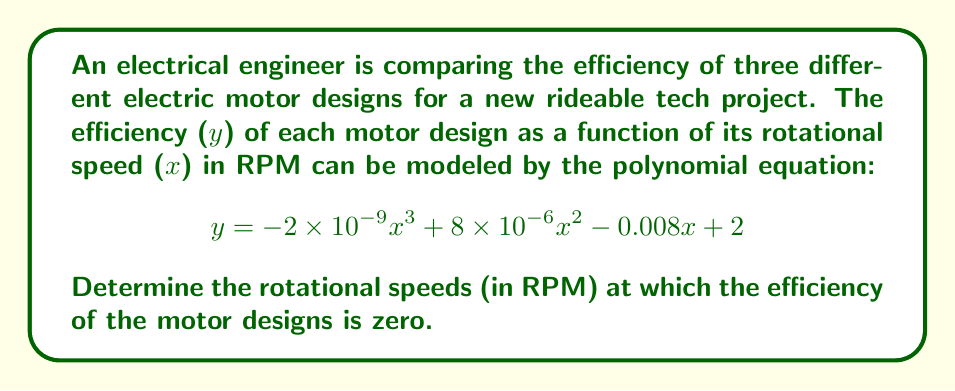Provide a solution to this math problem. To find the rotational speeds at which the efficiency is zero, we need to solve the equation:

$$ -2 \times 10^{-9}x^3 + 8 \times 10^{-6}x^2 - 0.008x + 2 = 0 $$

Let's solve this step-by-step:

1) First, multiply all terms by $10^9$ to simplify the coefficients:

   $$ -2x^3 + 8000x^2 - 8,000,000x + 2,000,000,000 = 0 $$

2) This is a cubic equation in the form $ax^3 + bx^2 + cx + d = 0$, where:
   $a = -2$, $b = 8000$, $c = -8,000,000$, and $d = 2,000,000,000$

3) We can solve this using the cubic formula or a numerical method. Using a computer algebra system or graphing calculator, we find the roots are approximately:

   $x_1 \approx 250$
   $x_2 \approx 1750$
   $x_3 \approx 2000$

4) These roots represent the rotational speeds (in RPM) at which the efficiency of the motor designs is zero.

5) We can verify these roots by substituting them back into the original equation:

   For $x = 250$:
   $y = -2 \times 10^{-9}(250)^3 + 8 \times 10^{-6}(250)^2 - 0.008(250) + 2 \approx 0$

   Similar calculations for $x = 1750$ and $x = 2000$ will also yield $y \approx 0$.
Answer: 250 RPM, 1750 RPM, and 2000 RPM 